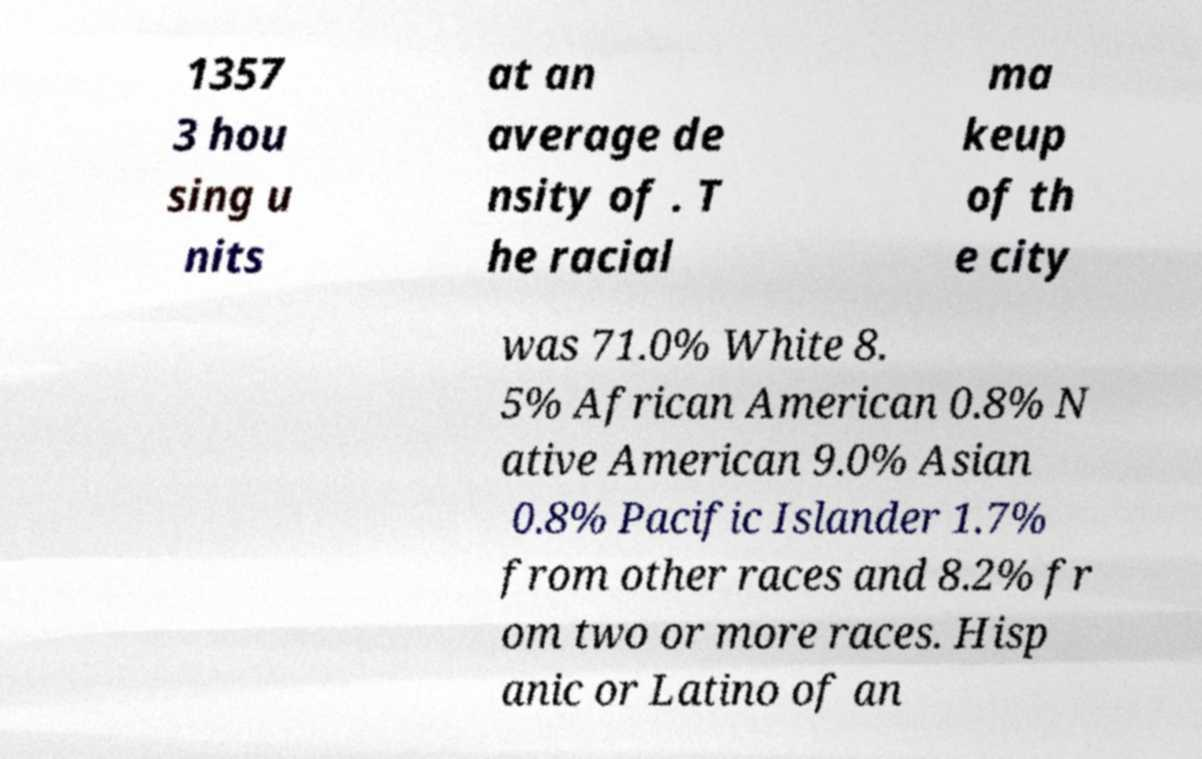Could you assist in decoding the text presented in this image and type it out clearly? 1357 3 hou sing u nits at an average de nsity of . T he racial ma keup of th e city was 71.0% White 8. 5% African American 0.8% N ative American 9.0% Asian 0.8% Pacific Islander 1.7% from other races and 8.2% fr om two or more races. Hisp anic or Latino of an 